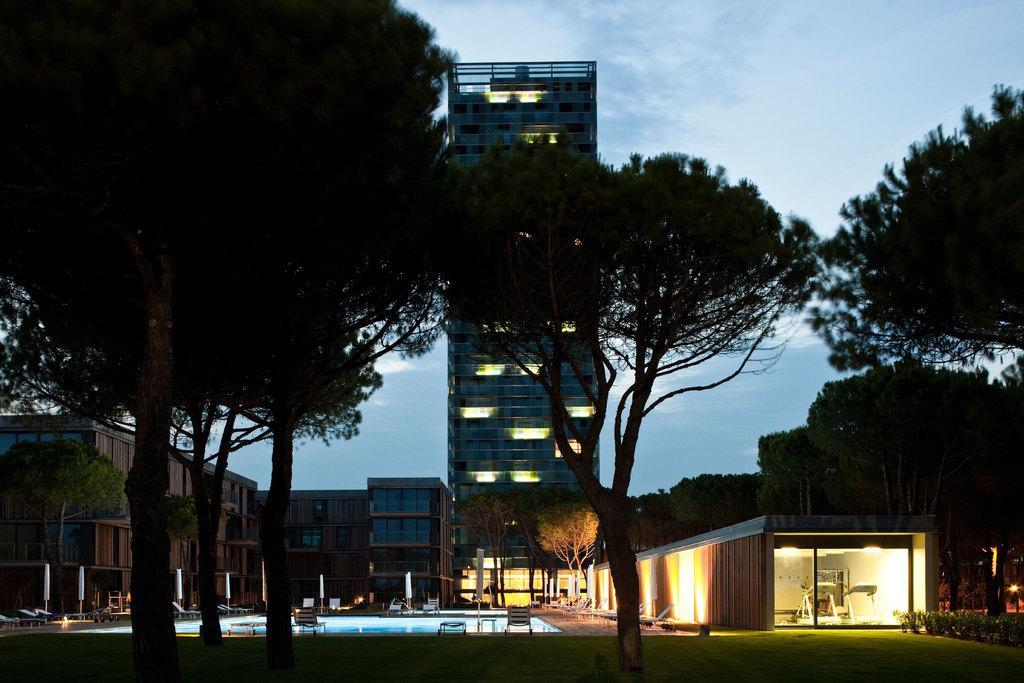Could you give a brief overview of what you see in this image? In this image we can see some trees at the foreground of the image and at the background of the image there are buildings, swimming pool, chairs, beach benches and at the top of the image there is clear sky. 